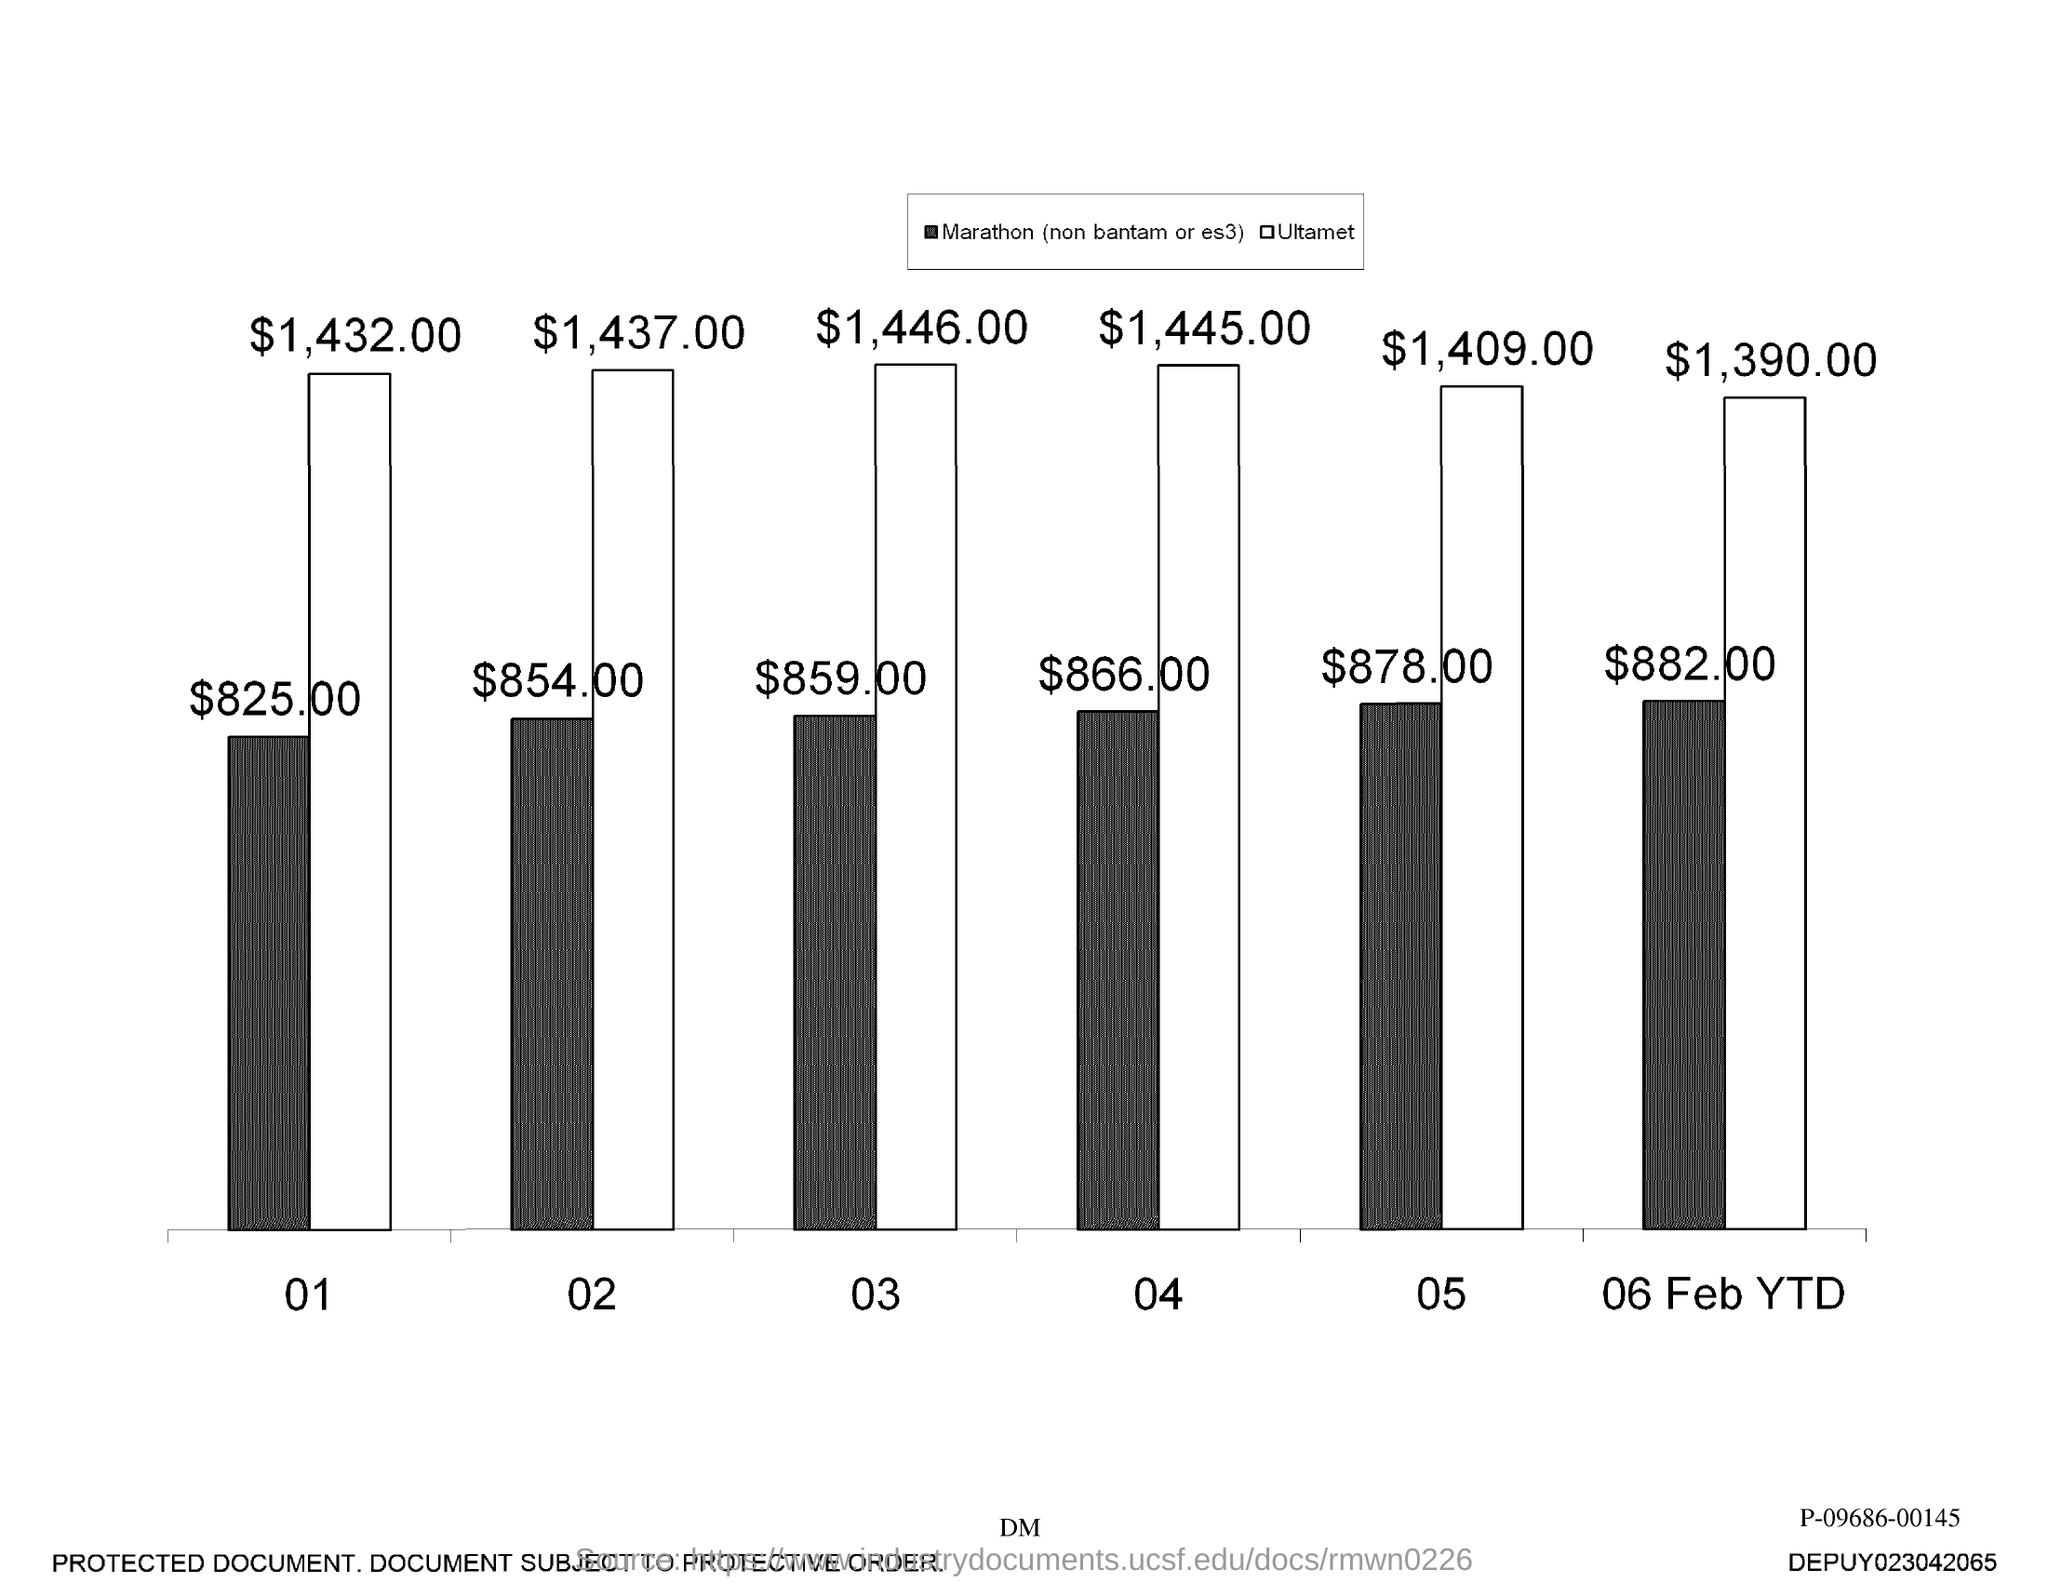What is the highest value in the graph?
Provide a short and direct response. $1,446.00. 